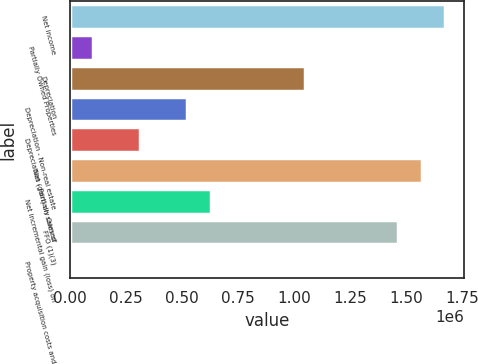Convert chart. <chart><loc_0><loc_0><loc_500><loc_500><bar_chart><fcel>Net income<fcel>Partially Owned Properties<fcel>Depreciation<fcel>Depreciation - Non-real estate<fcel>Depreciation - Partially Owned<fcel>Net (gain) on sales of<fcel>Net incremental gain (loss) on<fcel>FFO (1)(3)<fcel>Property acquisition costs and<nl><fcel>1.67467e+06<fcel>106383<fcel>1.04736e+06<fcel>524593<fcel>315488<fcel>1.57012e+06<fcel>629146<fcel>1.46557e+06<fcel>1830<nl></chart> 